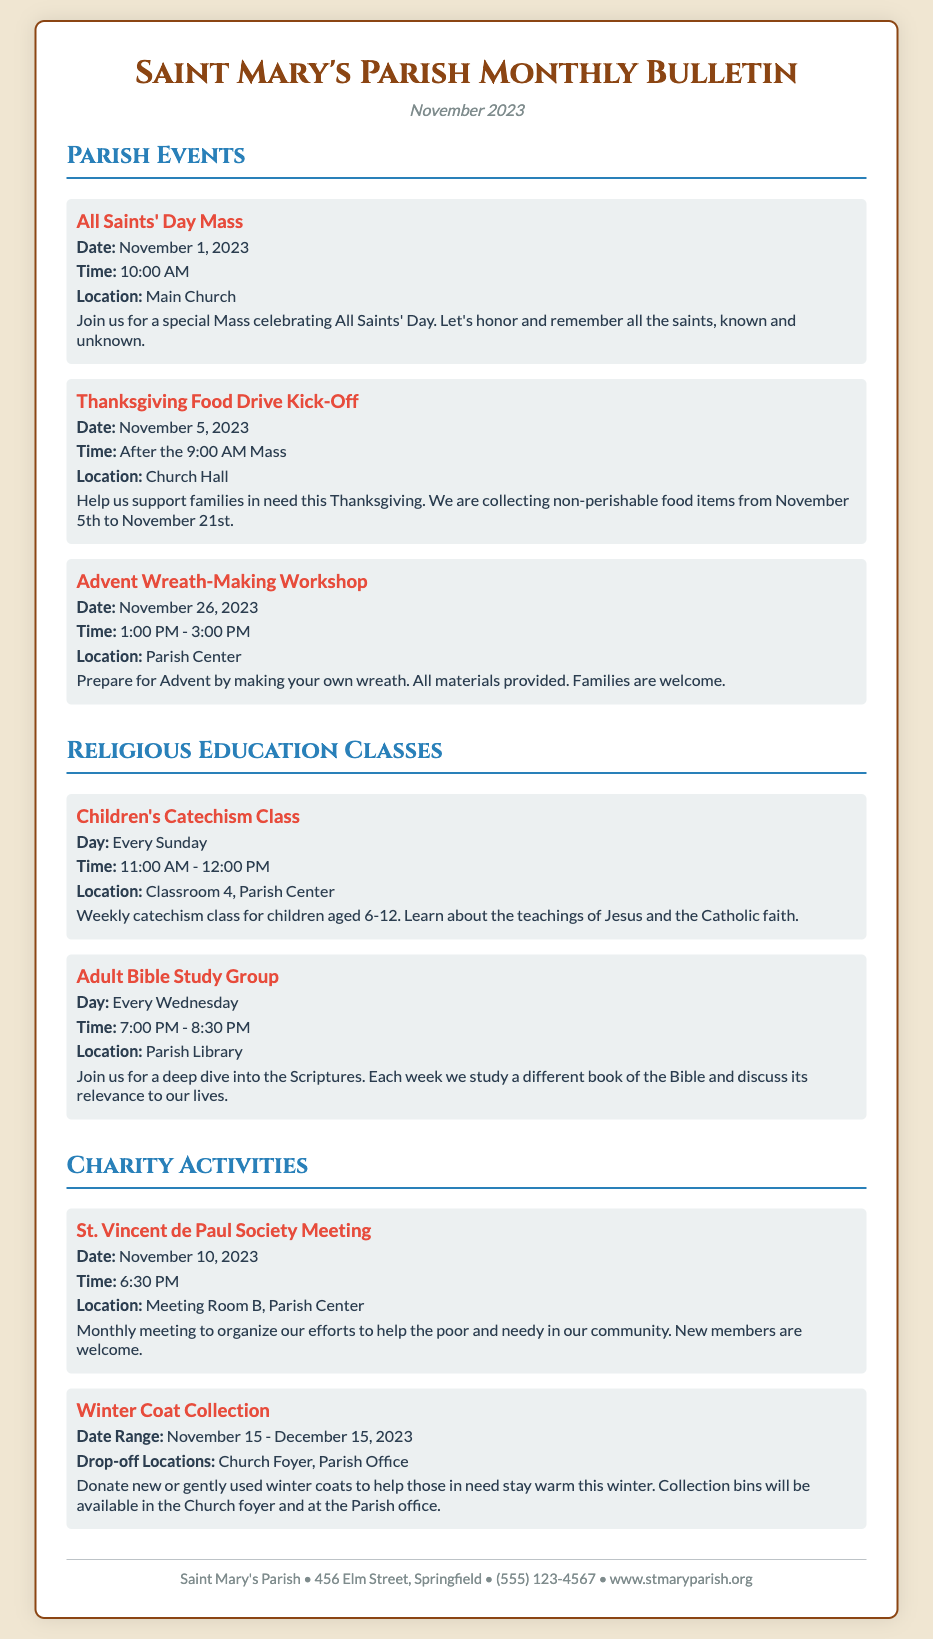What date is the All Saints' Day Mass? The date for the All Saints' Day Mass is mentioned in the document as November 1, 2023.
Answer: November 1, 2023 What time does the Thanksgiving Food Drive Kick-Off start? The time for the Thanksgiving Food Drive Kick-Off is specified in the document as after the 9:00 AM Mass.
Answer: After the 9:00 AM Mass Where is the Advent Wreath-Making Workshop located? The location for the Advent Wreath-Making Workshop is provided as the Parish Center.
Answer: Parish Center What day of the week are the Children's Catechism Classes held? The day for the Children's Catechism Classes is indicated as every Sunday in the document.
Answer: Every Sunday What is the duration of the Adult Bible Study Group? The duration of the Adult Bible Study Group is specified as 1.5 hours, from 7:00 PM to 8:30 PM.
Answer: 1.5 hours When does the Winter Coat Collection begin? The start date for the Winter Coat Collection is mentioned as November 15, 2023.
Answer: November 15, 2023 What is the primary purpose of the St. Vincent de Paul Society Meeting? The document states that the meeting is to organize efforts to help the poor and needy in the community.
Answer: Help the poor and needy What materials are provided for the Advent Wreath-Making Workshop? The document notes that all materials for the workshop are provided for the participants.
Answer: All materials provided Where can donations for the Winter Coat Collection be dropped off? The document specifies two drop-off locations: Church Foyer and Parish Office.
Answer: Church Foyer, Parish Office 